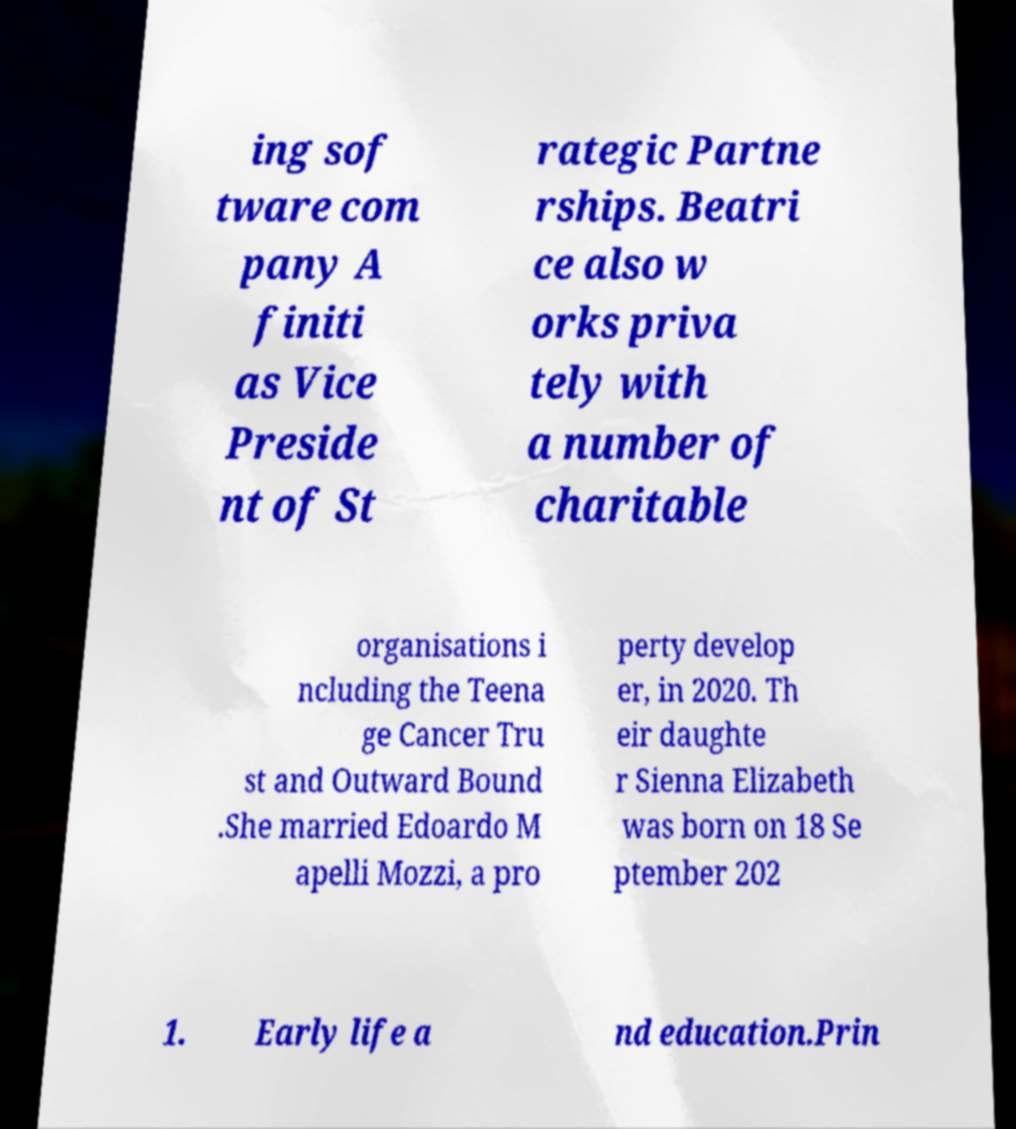What messages or text are displayed in this image? I need them in a readable, typed format. ing sof tware com pany A finiti as Vice Preside nt of St rategic Partne rships. Beatri ce also w orks priva tely with a number of charitable organisations i ncluding the Teena ge Cancer Tru st and Outward Bound .She married Edoardo M apelli Mozzi, a pro perty develop er, in 2020. Th eir daughte r Sienna Elizabeth was born on 18 Se ptember 202 1. Early life a nd education.Prin 